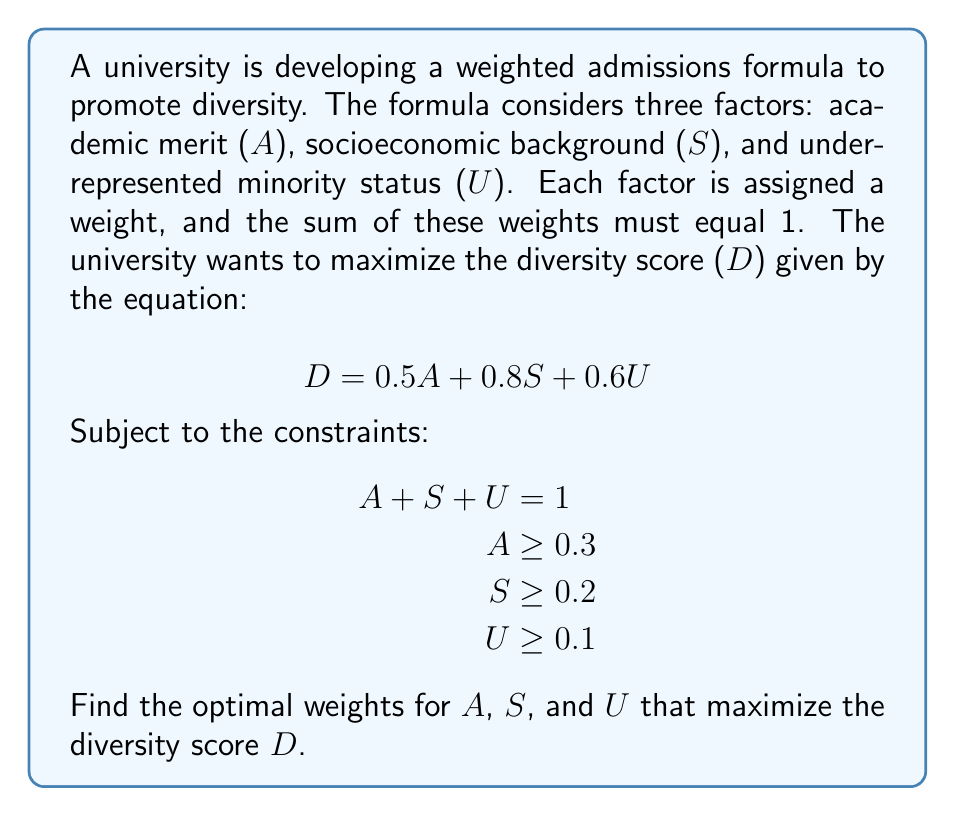What is the answer to this math problem? To solve this optimization problem, we'll use the method of linear programming:

1) First, let's write our objective function:
   $$D = 0.5A + 0.8S + 0.6U$$ (maximize this)

2) Subject to the constraints:
   $$A + S + U = 1$$
   $$A \geq 0.3$$
   $$S \geq 0.2$$
   $$U \geq 0.1$$

3) Given these constraints, we can see that S has the highest coefficient (0.8) in the objective function. Therefore, we should maximize S first.

4) The maximum value for S is:
   $$S = 1 - A - U$$
   $$S = 1 - 0.3 - 0.1 = 0.6$$
   This satisfies $S \geq 0.2$

5) Now we have:
   $$A = 0.3$$
   $$S = 0.6$$
   $$U = 0.1$$

6) Let's verify that this solution maximizes D:
   $$D = 0.5(0.3) + 0.8(0.6) + 0.6(0.1)$$
   $$D = 0.15 + 0.48 + 0.06 = 0.69$$

7) Any other combination that satisfies the constraints will yield a lower D value.
Answer: The optimal weights that maximize the diversity score are:
$$A = 0.3$$
$$S = 0.6$$
$$U = 0.1$$
resulting in a maximum diversity score of $D = 0.69$. 